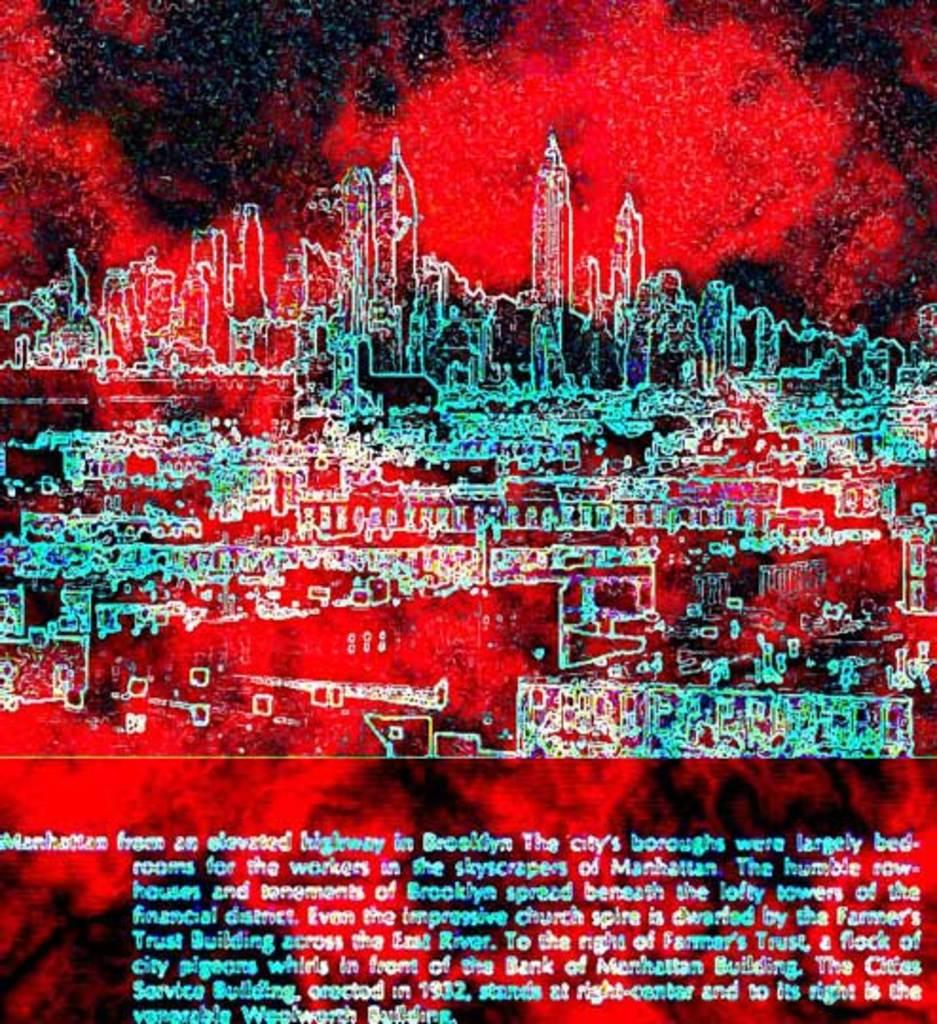What type of image is being described? The image is graphical in nature. What can be seen in the graphical image? There are buildings depicted in the image. Are there any words or letters in the image? Yes, there is text present in the image. How many baseballs are visible in the image? There are no baseballs present in the image. What shape is the circle in the image? There is no circle present in the image. 